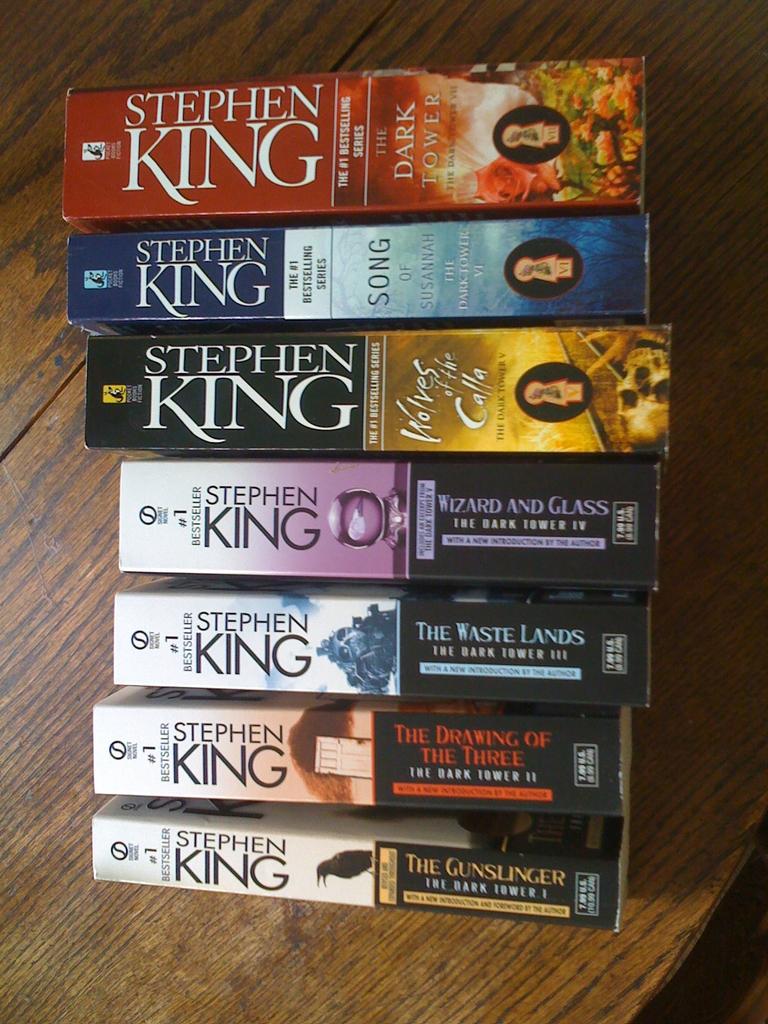What is this series called?
Make the answer very short. The dark tower. 